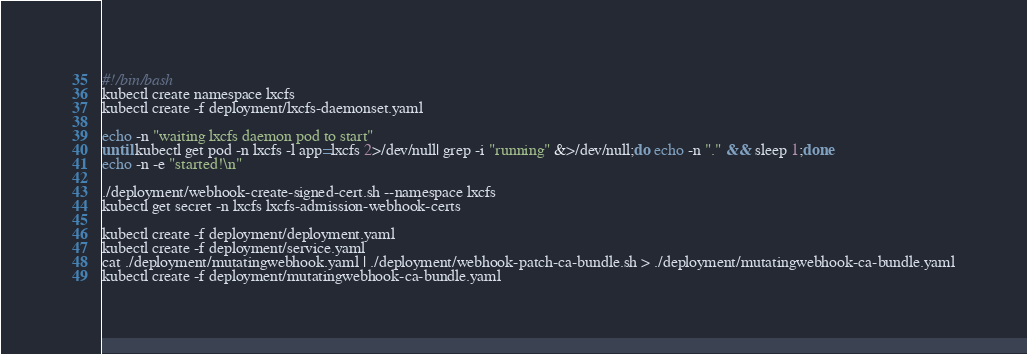Convert code to text. <code><loc_0><loc_0><loc_500><loc_500><_Bash_>#!/bin/bash
kubectl create namespace lxcfs
kubectl create -f deployment/lxcfs-daemonset.yaml

echo -n "waiting lxcfs daemon pod to start"
until kubectl get pod -n lxcfs -l app=lxcfs 2>/dev/null| grep -i "running" &>/dev/null;do echo -n "." && sleep 1;done
echo -n -e "started!\n"

./deployment/webhook-create-signed-cert.sh --namespace lxcfs
kubectl get secret -n lxcfs lxcfs-admission-webhook-certs

kubectl create -f deployment/deployment.yaml
kubectl create -f deployment/service.yaml
cat ./deployment/mutatingwebhook.yaml | ./deployment/webhook-patch-ca-bundle.sh > ./deployment/mutatingwebhook-ca-bundle.yaml
kubectl create -f deployment/mutatingwebhook-ca-bundle.yaml

</code> 